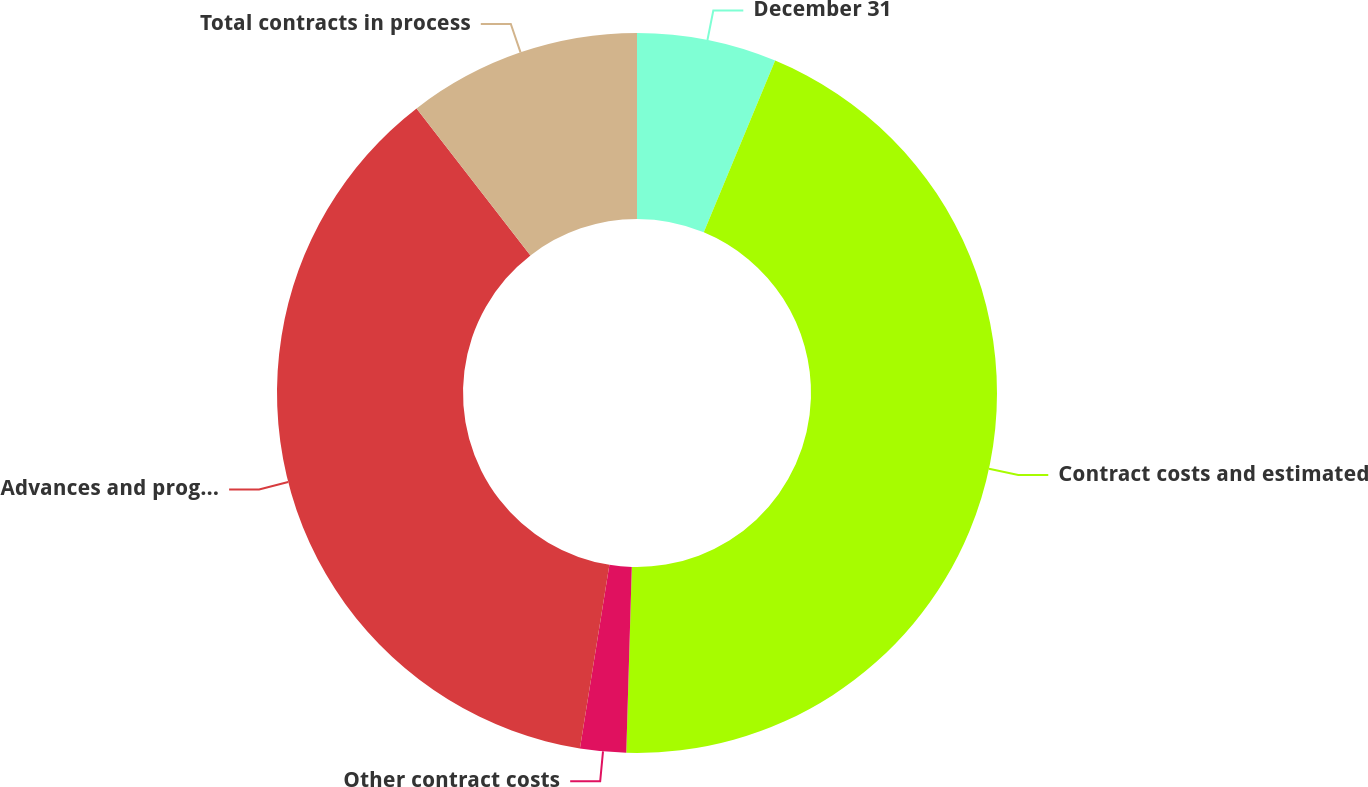Convert chart. <chart><loc_0><loc_0><loc_500><loc_500><pie_chart><fcel>December 31<fcel>Contract costs and estimated<fcel>Other contract costs<fcel>Advances and progress payments<fcel>Total contracts in process<nl><fcel>6.27%<fcel>44.21%<fcel>2.06%<fcel>36.98%<fcel>10.49%<nl></chart> 